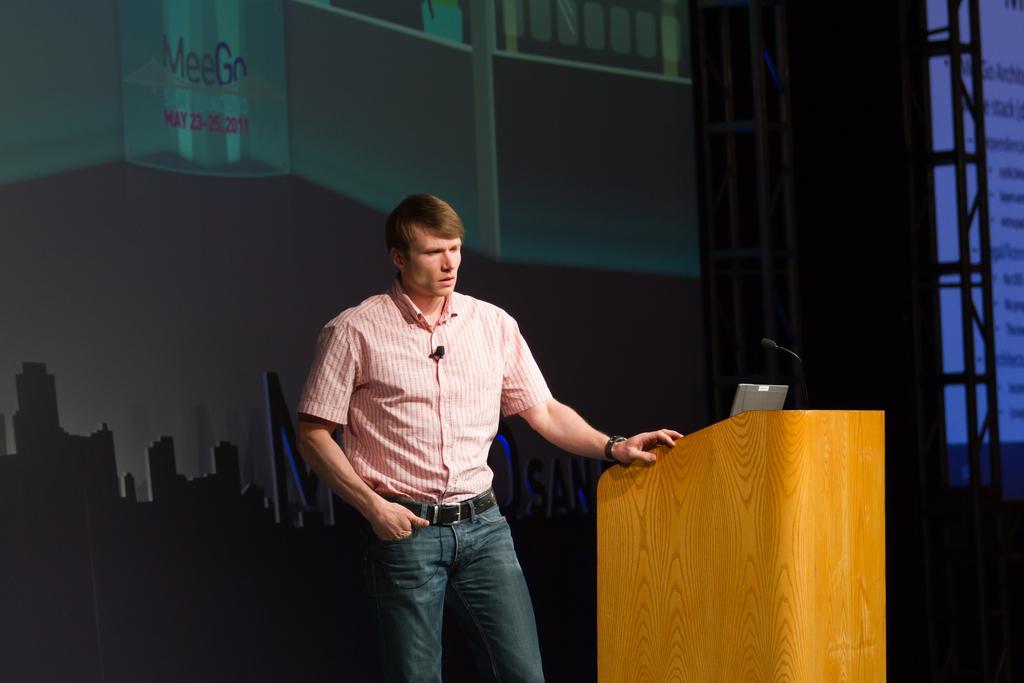Can you describe this image briefly? In this image there is a man standing towards the bottom of the image, there is a podium towards the bottom of the image, there are objects on the podium, there is a screen towards the right of the image, there is text on the screen, there are metal objects towards the top of the image, at the background of the image there is an object that looks like a board, there are buildings on the board, there is text on the board, there are numbers on the board. 